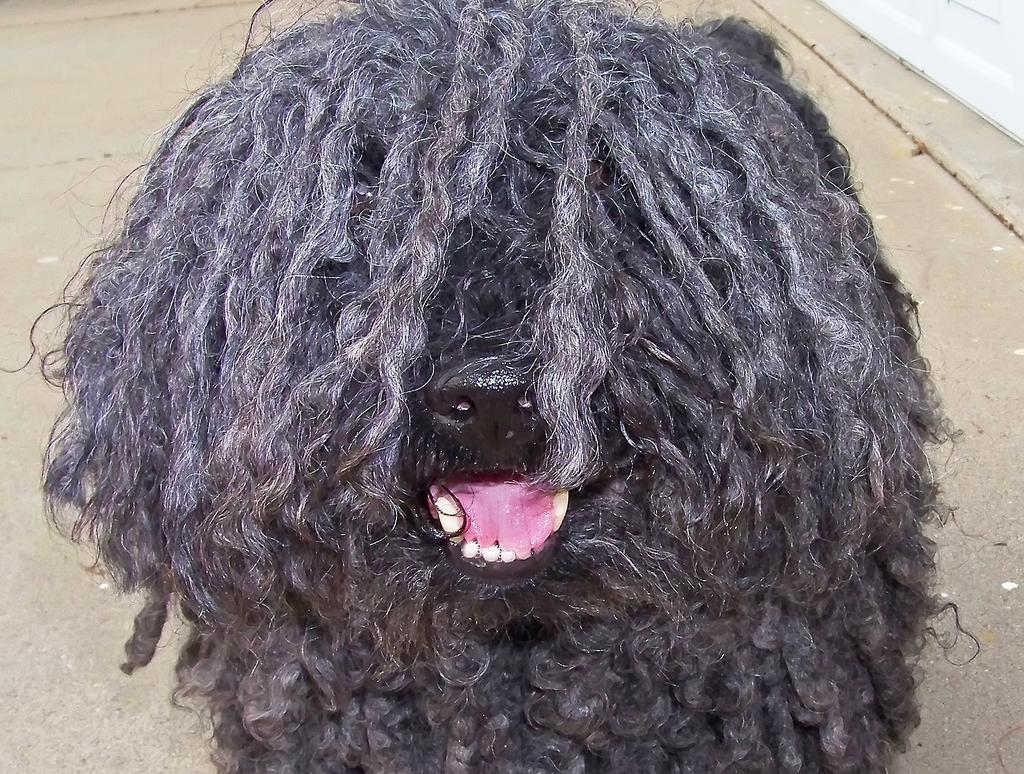What type of animal is in the image? There is a dog in the image. What color is the dog? The dog is black in color. What is a characteristic of the dog's appearance? The dog is full of hair. What other object is present in the image? There is a rod in the image. What flavor of prose can be tasted in the image? There is no prose present in the image, and therefore no flavor can be tasted. Does the existence of the dog in the image prove the existence of a parallel universe? The presence of the dog in the image does not prove the existence of a parallel universe, as the image is a representation of a single reality. 